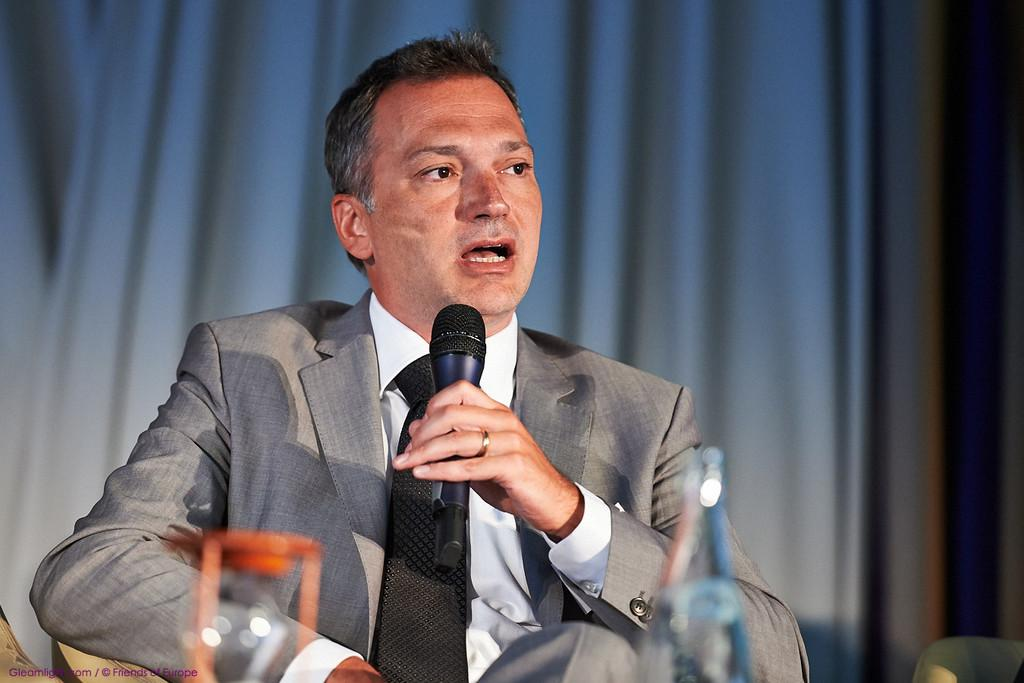Who is the main subject in the image? There is a man in the image. What is the man doing in the image? The man is sitting on a chair and speaking. What is the man holding in his left hand? The man is holding a microphone in his left hand. What is the man wearing in the image? The man is wearing a suit. What type of trouble are the dinosaurs causing in the image? There are no dinosaurs present in the image, so it is not possible to determine if they are causing any trouble. 